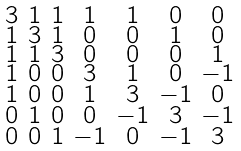<formula> <loc_0><loc_0><loc_500><loc_500>\begin{smallmatrix} 3 & 1 & 1 & 1 & 1 & 0 & 0 \\ 1 & 3 & 1 & 0 & 0 & 1 & 0 \\ 1 & 1 & 3 & 0 & 0 & 0 & 1 \\ 1 & 0 & 0 & 3 & 1 & 0 & - 1 \\ 1 & 0 & 0 & 1 & 3 & - 1 & 0 \\ 0 & 1 & 0 & 0 & - 1 & 3 & - 1 \\ 0 & 0 & 1 & - 1 & 0 & - 1 & 3 \end{smallmatrix}</formula> 